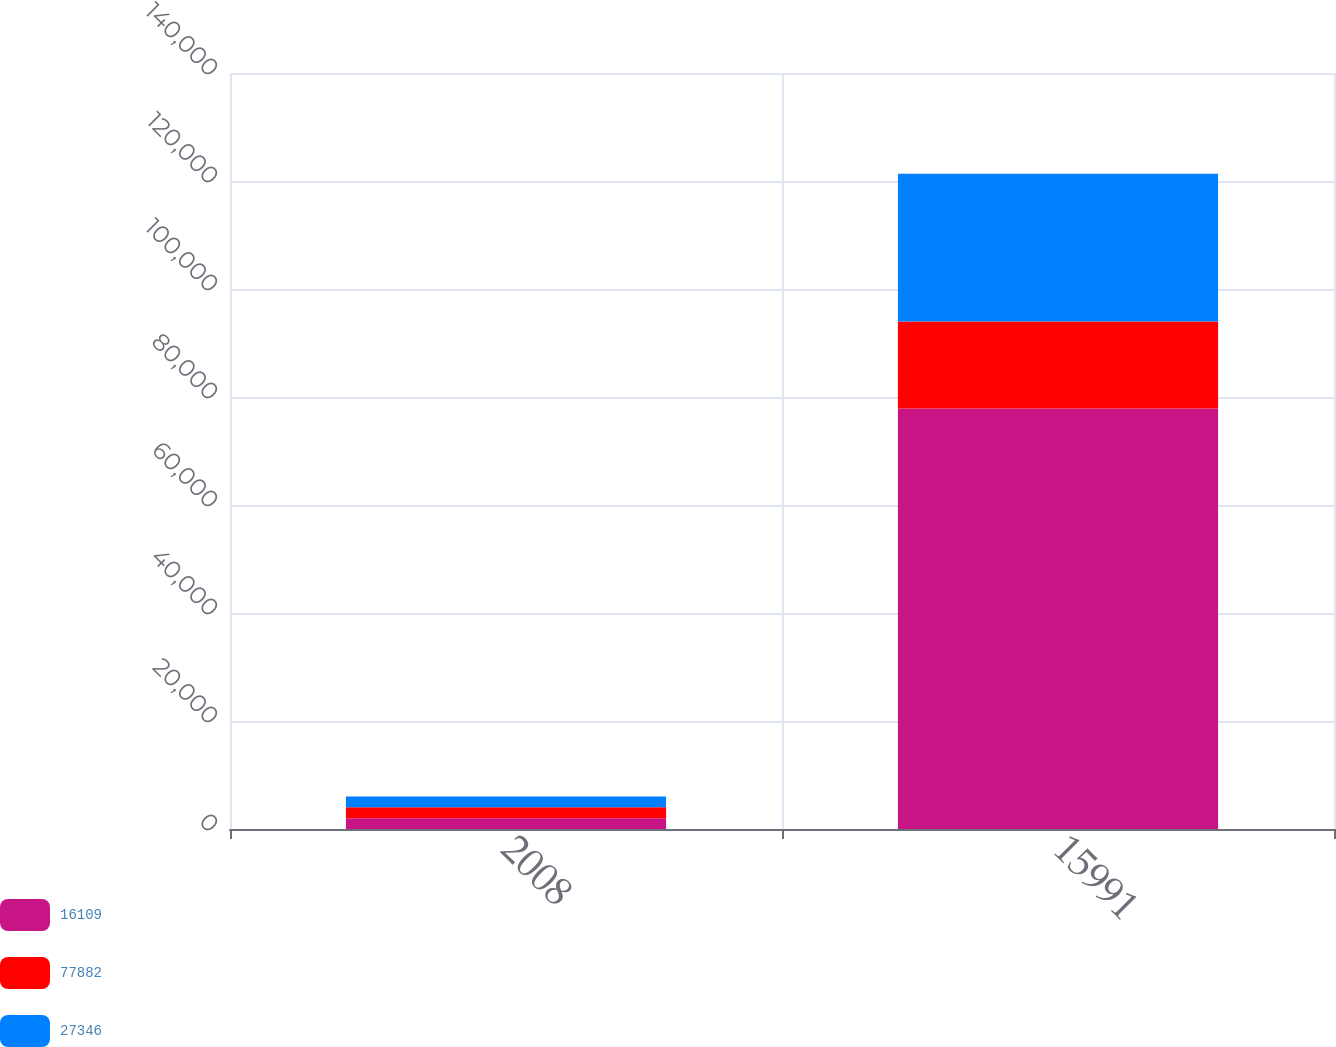Convert chart to OTSL. <chart><loc_0><loc_0><loc_500><loc_500><stacked_bar_chart><ecel><fcel>2008<fcel>15991<nl><fcel>16109<fcel>2007<fcel>77882<nl><fcel>77882<fcel>2006<fcel>16109<nl><fcel>27346<fcel>2005<fcel>27346<nl></chart> 